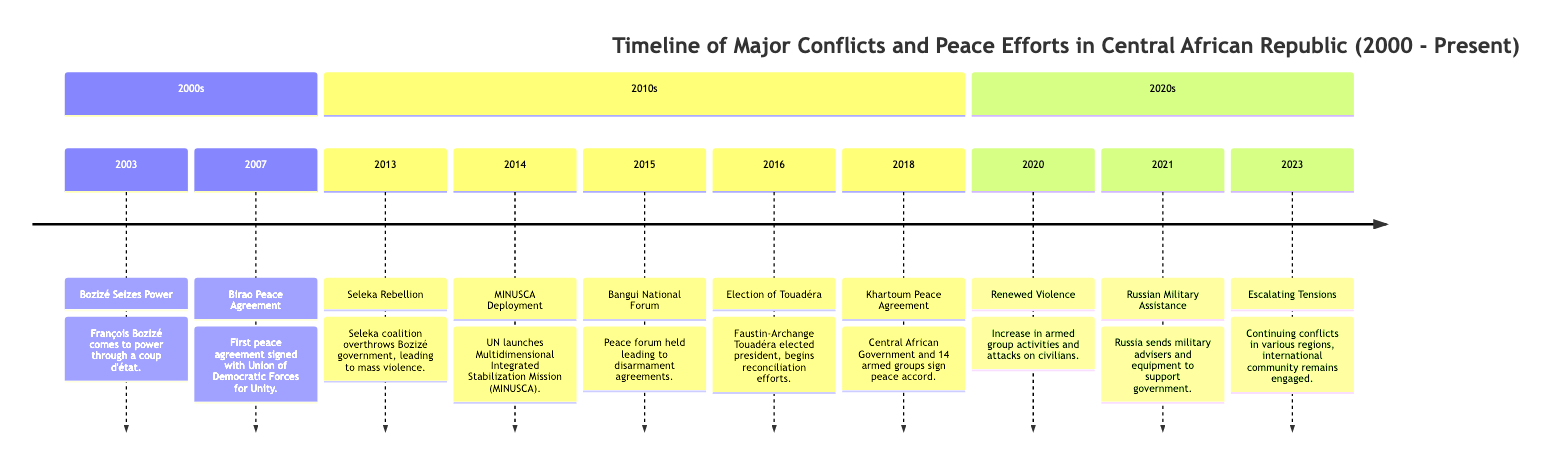What significant event occurred in 2003? The diagram specifies that in 2003, François Bozizé comes to power through a coup d'état. This is explicitly stated in the timeline section for the 2000s.
Answer: Bozizé Seizes Power How many peace efforts are listed in the timeline? To answer this, I count the events specifically categorized as peace agreements or forums. The events in this category are Birao Peace Agreement (2007), Bangui National Forum (2015), and Khartoum Peace Agreement (2018), totaling three.
Answer: 3 Which armed group was involved in the 2013 rebellion? The diagram shows that the Seleka coalition was responsible for the rebellion in 2013 that overthrew the Bozizé government.
Answer: Seleka coalition What major international intervention occurred in 2014? In 2014, the UN launched the Multidimensional Integrated Stabilization Mission (MINUSCA). This event is marked in the 2010s section of the timeline.
Answer: MINUSCA Deployment What happened in 2020 that indicates a change in the conflict situation? The timeline indicates that in 2020, there was a Renewed Violence with an increase in armed group activities and attacks on civilians. This signifies a worsening situation.
Answer: Renewed Violence How many years passed between the Birao Peace Agreement and the Khartoum Peace Agreement? The Birao Peace Agreement occurred in 2007, and the Khartoum Peace Agreement took place in 2018. To find the difference, subtract 2007 from 2018, resulting in 11 years.
Answer: 11 years Which president was elected in 2016? According to the timeline, Faustin-Archange Touadéra was elected president in 2016. This information is presented directly in the timeline.
Answer: Touadéra What trend is seen in the 2023 entry of the timeline? The entry for 2023 indicates "Escalating Tensions" with continuing conflicts in various regions, suggesting a persistent state of unrest and instability in the Central African Republic.
Answer: Escalating Tensions What did Russia provide in 2021, according to the timeline? The timeline notes that in 2021, Russia sent military advisers and equipment to support the government, indicating an international involvement in the conflict.
Answer: Military assistance 